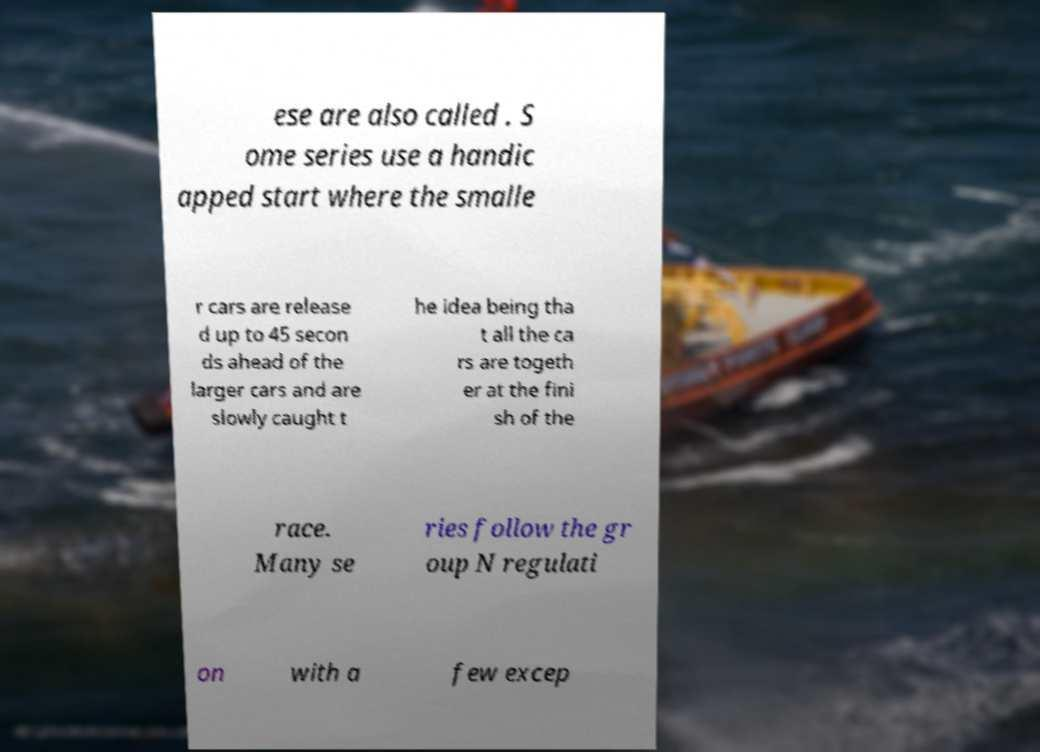For documentation purposes, I need the text within this image transcribed. Could you provide that? ese are also called . S ome series use a handic apped start where the smalle r cars are release d up to 45 secon ds ahead of the larger cars and are slowly caught t he idea being tha t all the ca rs are togeth er at the fini sh of the race. Many se ries follow the gr oup N regulati on with a few excep 